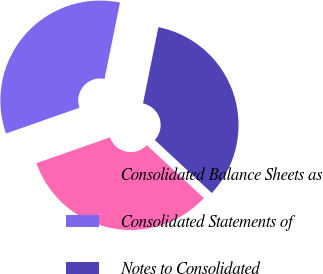Convert chart to OTSL. <chart><loc_0><loc_0><loc_500><loc_500><pie_chart><fcel>Consolidated Balance Sheets as<fcel>Consolidated Statements of<fcel>Notes to Consolidated<nl><fcel>32.71%<fcel>33.54%<fcel>33.75%<nl></chart> 